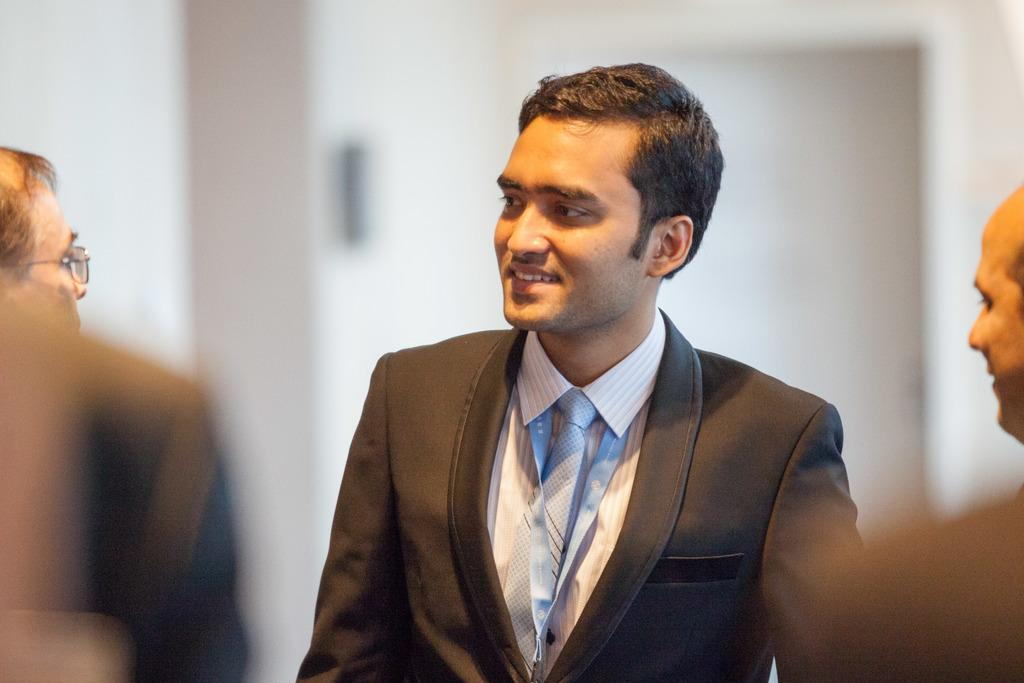How many people are in the image? There are persons in the image. Can you describe the man in the front of the image? The man in the front of the image is wearing a blazer and a tie. What expression does the man have? The man is smiling. What type of bun is the man holding in the image? There is no bun present in the image; the man is wearing a blazer and a tie. What is the man's head made of in the image? The man's head is made of flesh and bone, as it is a human head, not a specific material. 